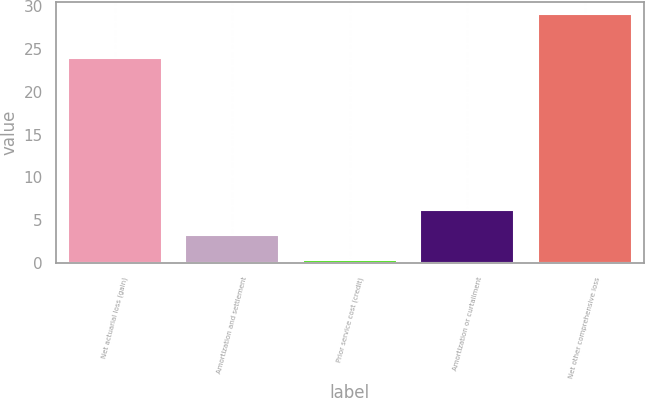<chart> <loc_0><loc_0><loc_500><loc_500><bar_chart><fcel>Net actuarial loss (gain)<fcel>Amortization and settlement<fcel>Prior service cost (credit)<fcel>Amortization or curtailment<fcel>Net other comprehensive loss<nl><fcel>23.9<fcel>3.27<fcel>0.4<fcel>6.14<fcel>29.1<nl></chart> 